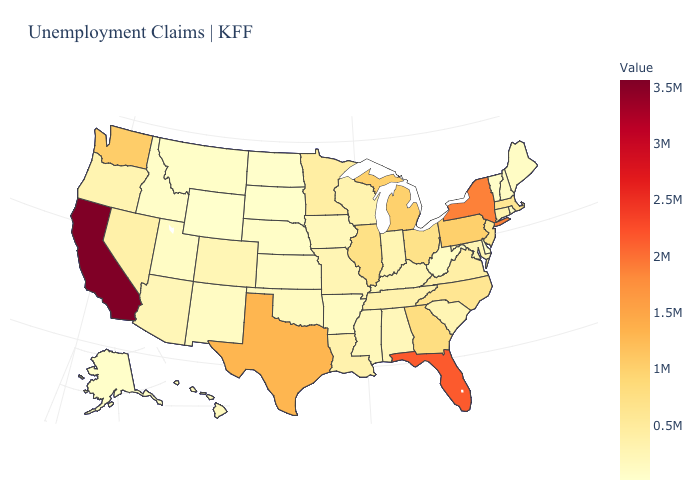Does Oregon have a lower value than Georgia?
Answer briefly. Yes. Does Wisconsin have the lowest value in the MidWest?
Write a very short answer. No. 